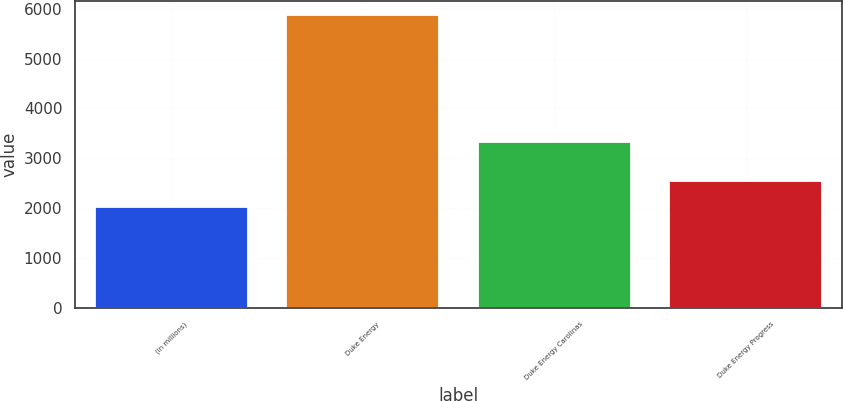Convert chart to OTSL. <chart><loc_0><loc_0><loc_500><loc_500><bar_chart><fcel>(in millions)<fcel>Duke Energy<fcel>Duke Energy Carolinas<fcel>Duke Energy Progress<nl><fcel>2017<fcel>5864<fcel>3321<fcel>2543<nl></chart> 